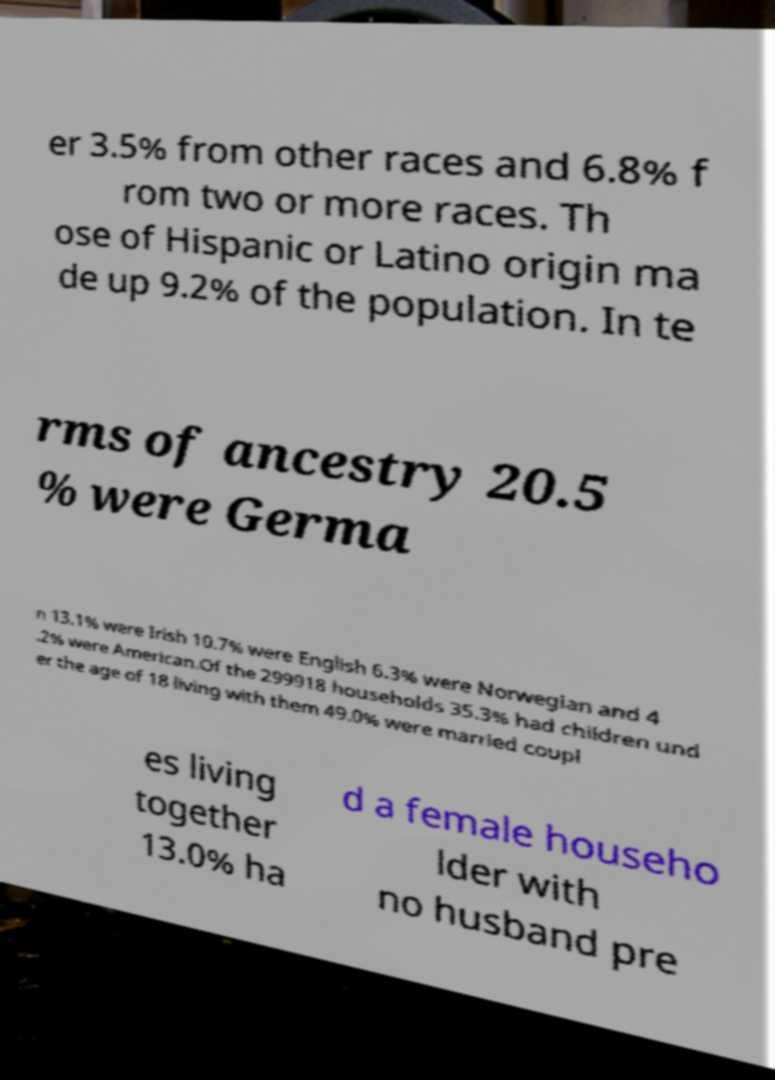Could you extract and type out the text from this image? er 3.5% from other races and 6.8% f rom two or more races. Th ose of Hispanic or Latino origin ma de up 9.2% of the population. In te rms of ancestry 20.5 % were Germa n 13.1% were Irish 10.7% were English 6.3% were Norwegian and 4 .2% were American.Of the 299918 households 35.3% had children und er the age of 18 living with them 49.0% were married coupl es living together 13.0% ha d a female househo lder with no husband pre 